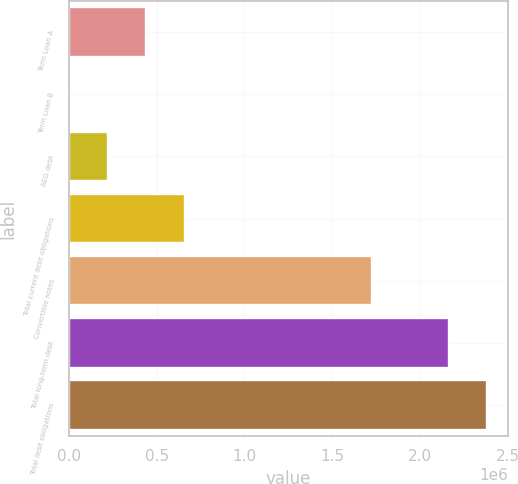Convert chart to OTSL. <chart><loc_0><loc_0><loc_500><loc_500><bar_chart><fcel>Term Loan A<fcel>Term Loan B<fcel>AEG debt<fcel>Total current debt obligations<fcel>Convertible notes<fcel>Total long-term debt<fcel>Total debt obligations<nl><fcel>441558<fcel>1723<fcel>221641<fcel>661476<fcel>1.725e+06<fcel>2.16242e+06<fcel>2.38234e+06<nl></chart> 